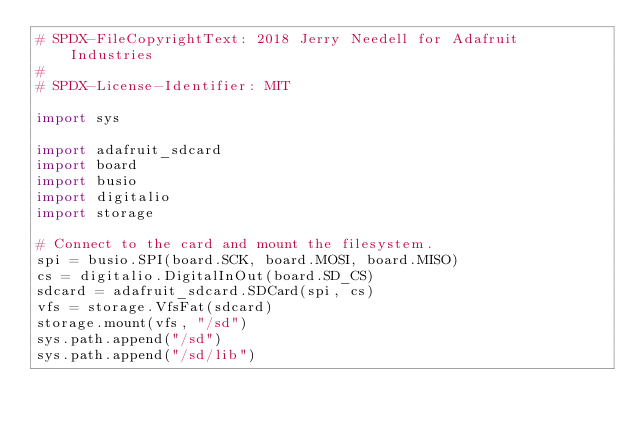<code> <loc_0><loc_0><loc_500><loc_500><_Python_># SPDX-FileCopyrightText: 2018 Jerry Needell for Adafruit Industries
#
# SPDX-License-Identifier: MIT

import sys

import adafruit_sdcard
import board
import busio
import digitalio
import storage

# Connect to the card and mount the filesystem.
spi = busio.SPI(board.SCK, board.MOSI, board.MISO)
cs = digitalio.DigitalInOut(board.SD_CS)
sdcard = adafruit_sdcard.SDCard(spi, cs)
vfs = storage.VfsFat(sdcard)
storage.mount(vfs, "/sd")
sys.path.append("/sd")
sys.path.append("/sd/lib")
</code> 